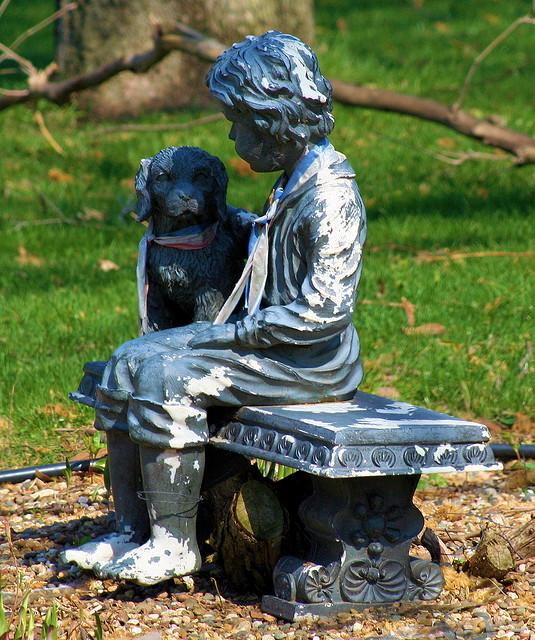Why is this statue partially white? Please explain your reasoning. bird droppings. Birds sit on it a lot and they poop everywhere 